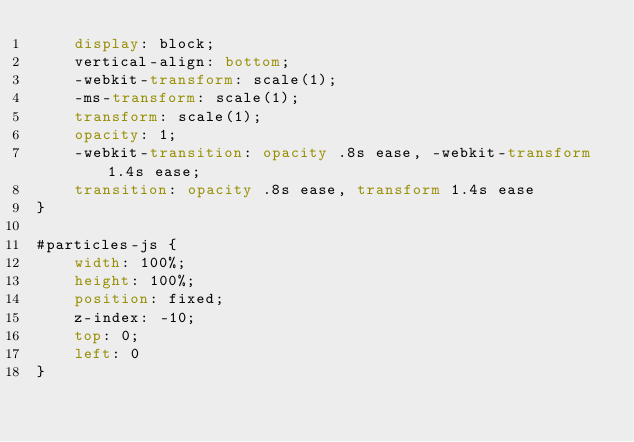Convert code to text. <code><loc_0><loc_0><loc_500><loc_500><_CSS_>    display: block;
    vertical-align: bottom;
    -webkit-transform: scale(1);
    -ms-transform: scale(1);
    transform: scale(1);
    opacity: 1;
    -webkit-transition: opacity .8s ease, -webkit-transform 1.4s ease;
    transition: opacity .8s ease, transform 1.4s ease
}

#particles-js {
    width: 100%;
    height: 100%;
    position: fixed;
    z-index: -10;
    top: 0;
    left: 0
}</code> 